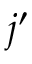Convert formula to latex. <formula><loc_0><loc_0><loc_500><loc_500>j ^ { \prime }</formula> 